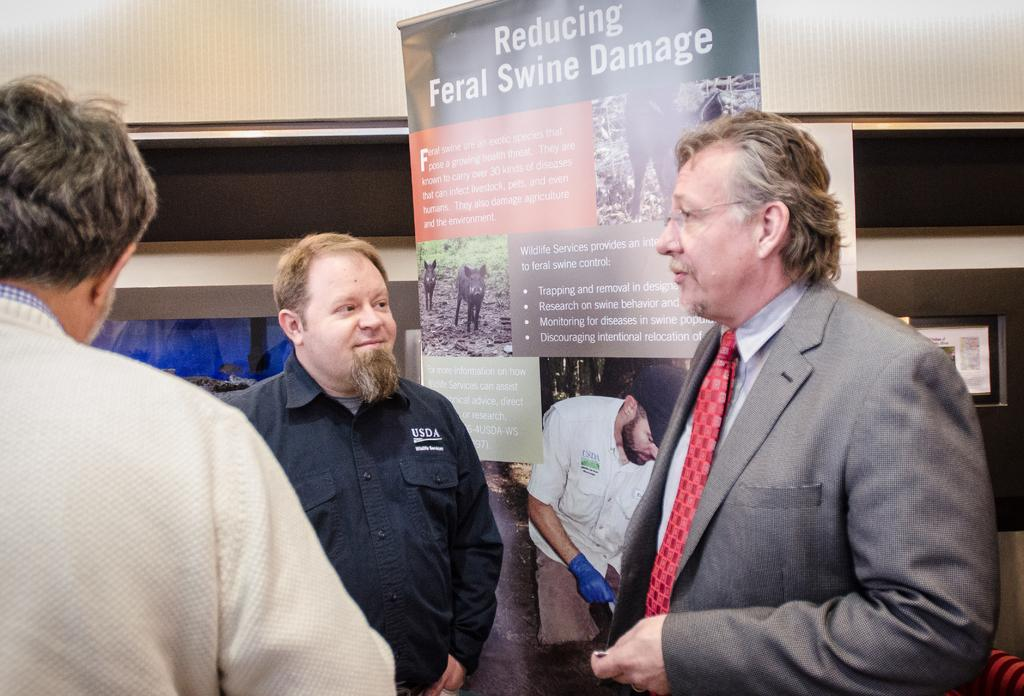How many people are in the image? There are three men standing in the image. What are the men wearing? The men are wearing clothes. What can be seen hanging or displayed in the image? There is a banner in the image. Can you describe the banner? The banner has text and pictures on it. What is visible in the background of the image? There is a wall visible in the image. What type of fruit is growing on the grass in the image? There is no fruit or grass present in the image. 